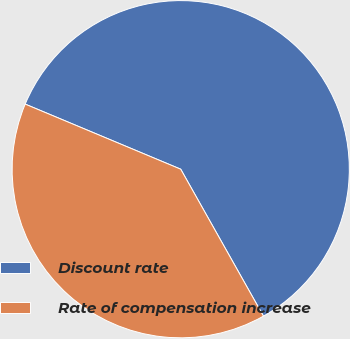<chart> <loc_0><loc_0><loc_500><loc_500><pie_chart><fcel>Discount rate<fcel>Rate of compensation increase<nl><fcel>60.53%<fcel>39.47%<nl></chart> 